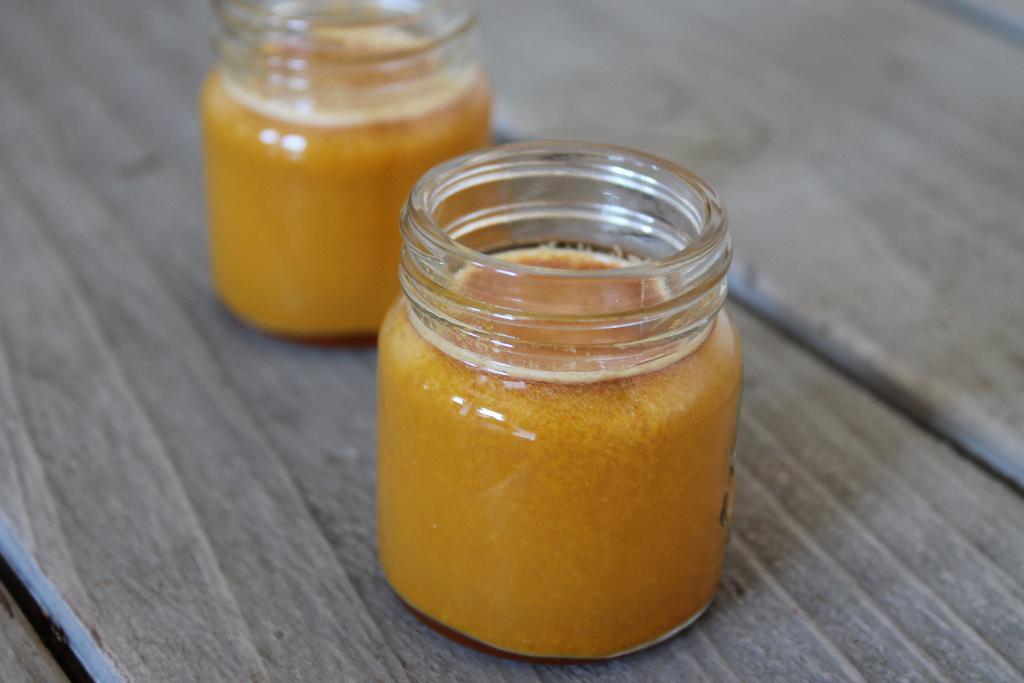How would you summarize this image in a sentence or two? In this image we can see food places in the glass jars on the wooden surface. 